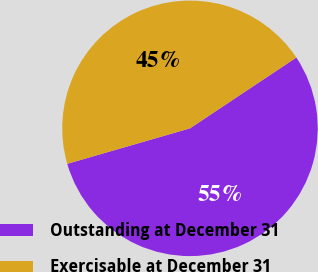<chart> <loc_0><loc_0><loc_500><loc_500><pie_chart><fcel>Outstanding at December 31<fcel>Exercisable at December 31<nl><fcel>54.87%<fcel>45.13%<nl></chart> 